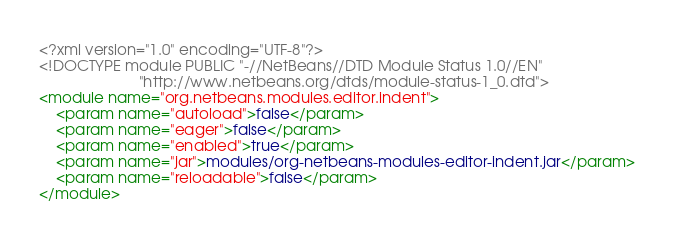Convert code to text. <code><loc_0><loc_0><loc_500><loc_500><_XML_><?xml version="1.0" encoding="UTF-8"?>
<!DOCTYPE module PUBLIC "-//NetBeans//DTD Module Status 1.0//EN"
                        "http://www.netbeans.org/dtds/module-status-1_0.dtd">
<module name="org.netbeans.modules.editor.indent">
    <param name="autoload">false</param>
    <param name="eager">false</param>
    <param name="enabled">true</param>
    <param name="jar">modules/org-netbeans-modules-editor-indent.jar</param>
    <param name="reloadable">false</param>
</module>
</code> 